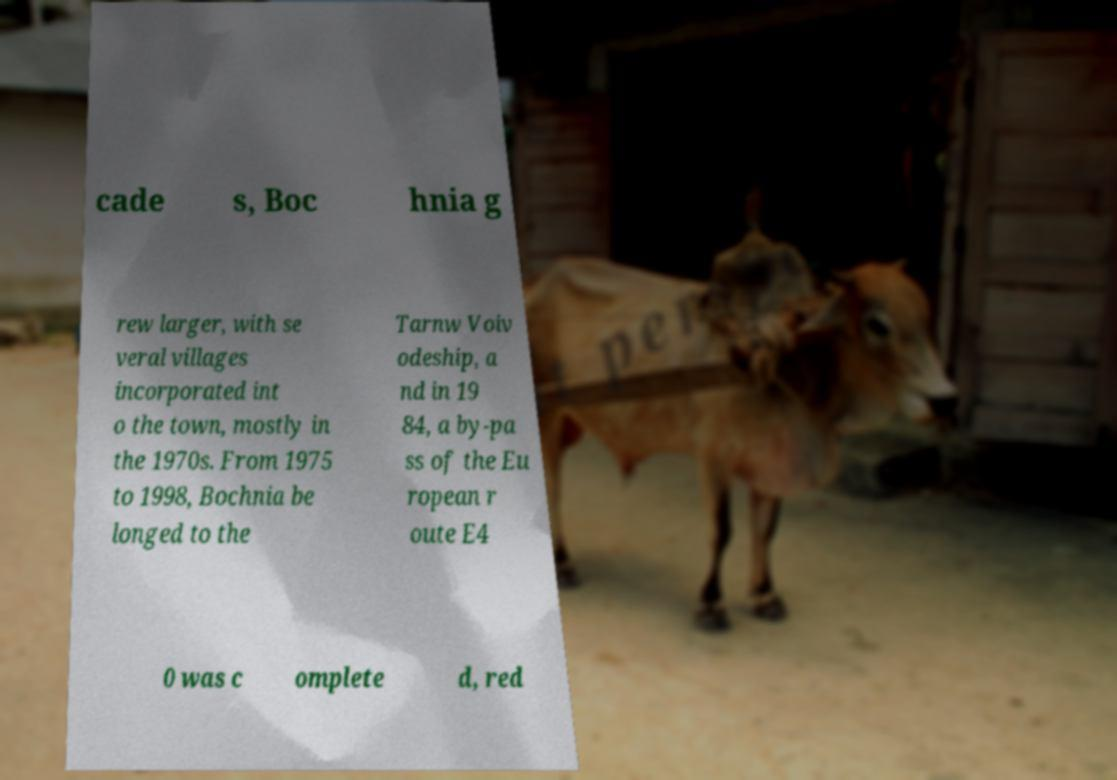Please identify and transcribe the text found in this image. cade s, Boc hnia g rew larger, with se veral villages incorporated int o the town, mostly in the 1970s. From 1975 to 1998, Bochnia be longed to the Tarnw Voiv odeship, a nd in 19 84, a by-pa ss of the Eu ropean r oute E4 0 was c omplete d, red 